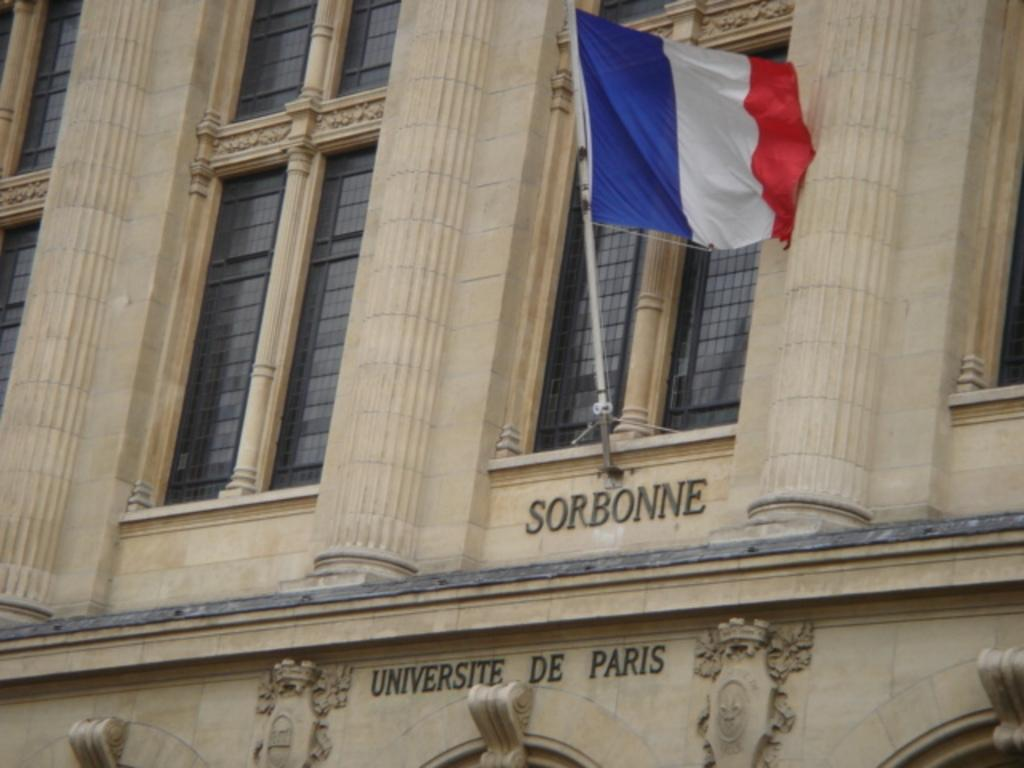What type of structure is visible in the image? There is a building in the image. What is attached to the flag in the image? There is a flag with a pole in the image. Are there any words or text visible on the building? Yes, there are words on the building. How many boats are visible in the image? There are no boats present in the image. What point is being made by the words on the building? The image does not provide enough context to determine the point being made by the words on the building. 